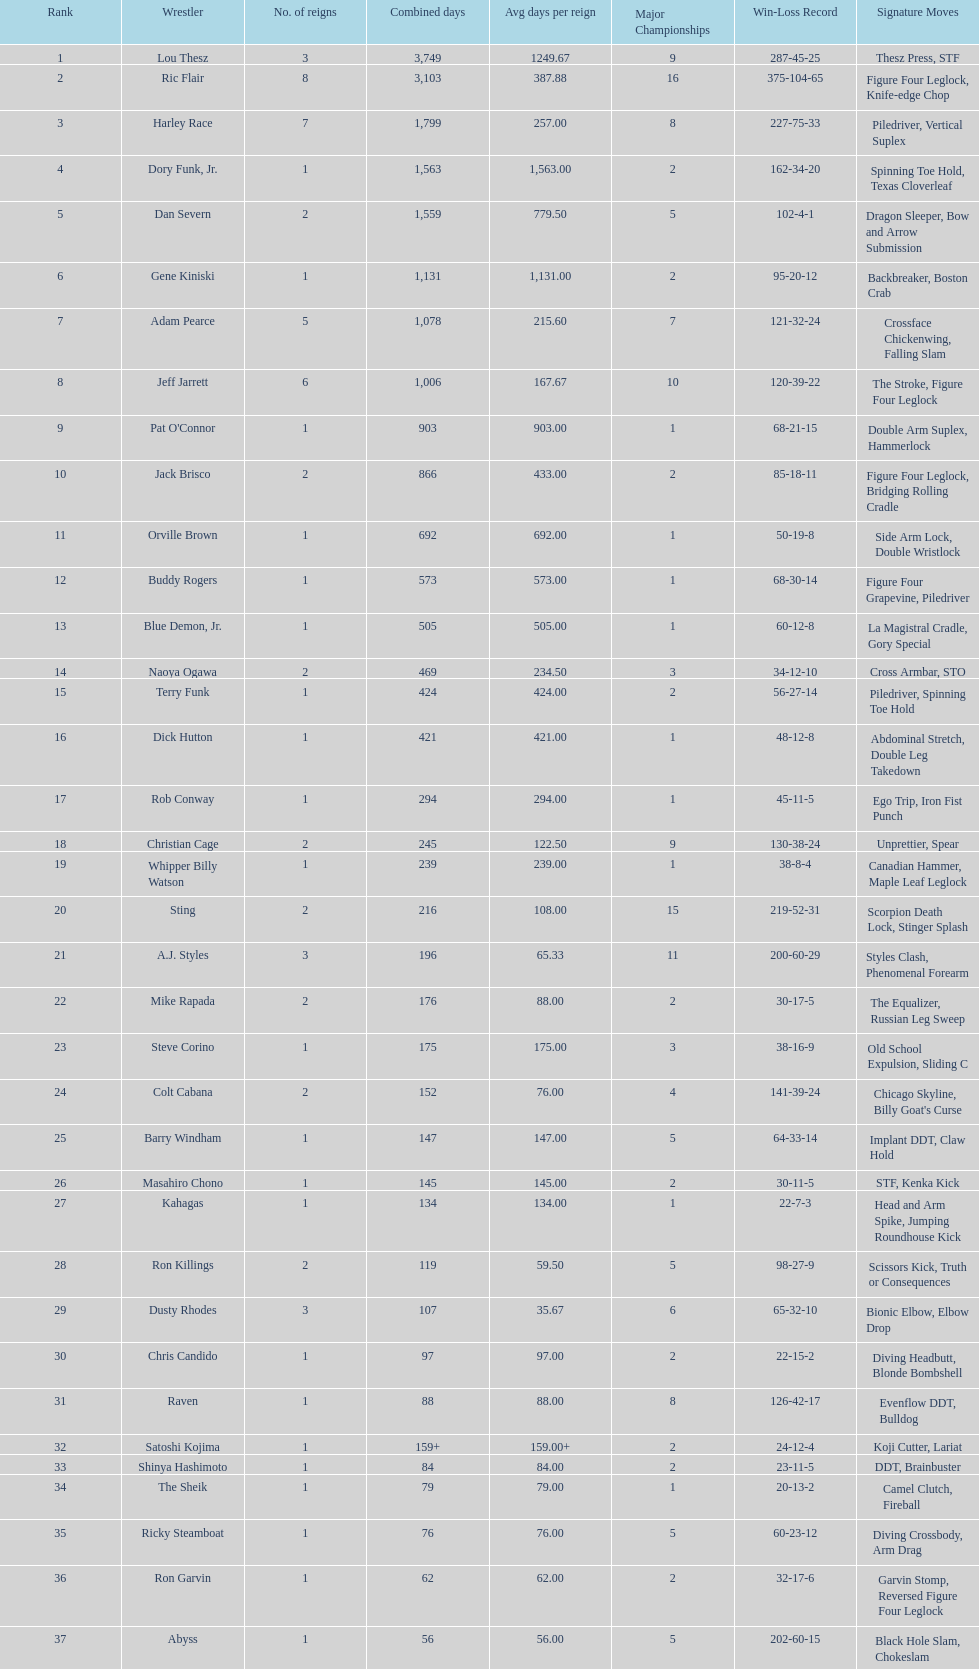Who has spent more time as nwa world heavyyweight champion, gene kiniski or ric flair? Ric Flair. 